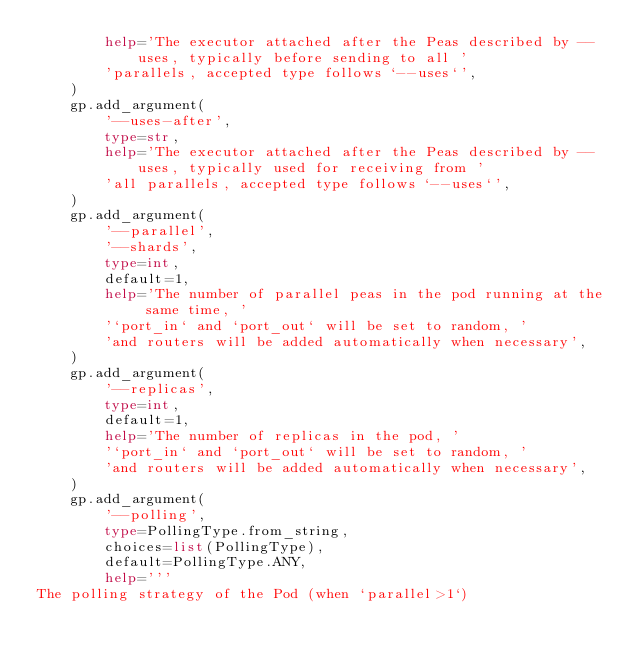<code> <loc_0><loc_0><loc_500><loc_500><_Python_>        help='The executor attached after the Peas described by --uses, typically before sending to all '
        'parallels, accepted type follows `--uses`',
    )
    gp.add_argument(
        '--uses-after',
        type=str,
        help='The executor attached after the Peas described by --uses, typically used for receiving from '
        'all parallels, accepted type follows `--uses`',
    )
    gp.add_argument(
        '--parallel',
        '--shards',
        type=int,
        default=1,
        help='The number of parallel peas in the pod running at the same time, '
        '`port_in` and `port_out` will be set to random, '
        'and routers will be added automatically when necessary',
    )
    gp.add_argument(
        '--replicas',
        type=int,
        default=1,
        help='The number of replicas in the pod, '
        '`port_in` and `port_out` will be set to random, '
        'and routers will be added automatically when necessary',
    )
    gp.add_argument(
        '--polling',
        type=PollingType.from_string,
        choices=list(PollingType),
        default=PollingType.ANY,
        help='''
The polling strategy of the Pod (when `parallel>1`)</code> 